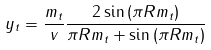<formula> <loc_0><loc_0><loc_500><loc_500>y _ { t } = \frac { m _ { t } } { v } \frac { 2 \sin \left ( \pi R m _ { t } \right ) } { \pi R m _ { t } + \sin \left ( \pi R m _ { t } \right ) }</formula> 